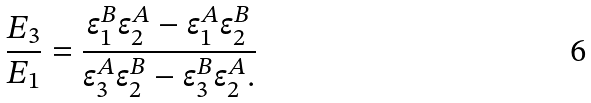Convert formula to latex. <formula><loc_0><loc_0><loc_500><loc_500>\frac { E _ { 3 } } { E _ { 1 } } = \frac { \epsilon _ { 1 } ^ { B } \epsilon _ { 2 } ^ { A } - \epsilon _ { 1 } ^ { A } \epsilon _ { 2 } ^ { B } } { \epsilon _ { 3 } ^ { A } \epsilon _ { 2 } ^ { B } - \epsilon _ { 3 } ^ { B } \epsilon _ { 2 } ^ { A } . }</formula> 